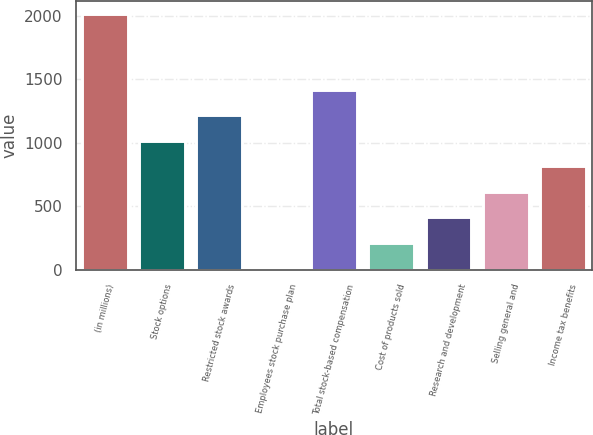Convert chart. <chart><loc_0><loc_0><loc_500><loc_500><bar_chart><fcel>(in millions)<fcel>Stock options<fcel>Restricted stock awards<fcel>Employees stock purchase plan<fcel>Total stock-based compensation<fcel>Cost of products sold<fcel>Research and development<fcel>Selling general and<fcel>Income tax benefits<nl><fcel>2015<fcel>1015<fcel>1215<fcel>15<fcel>1415<fcel>215<fcel>415<fcel>615<fcel>815<nl></chart> 